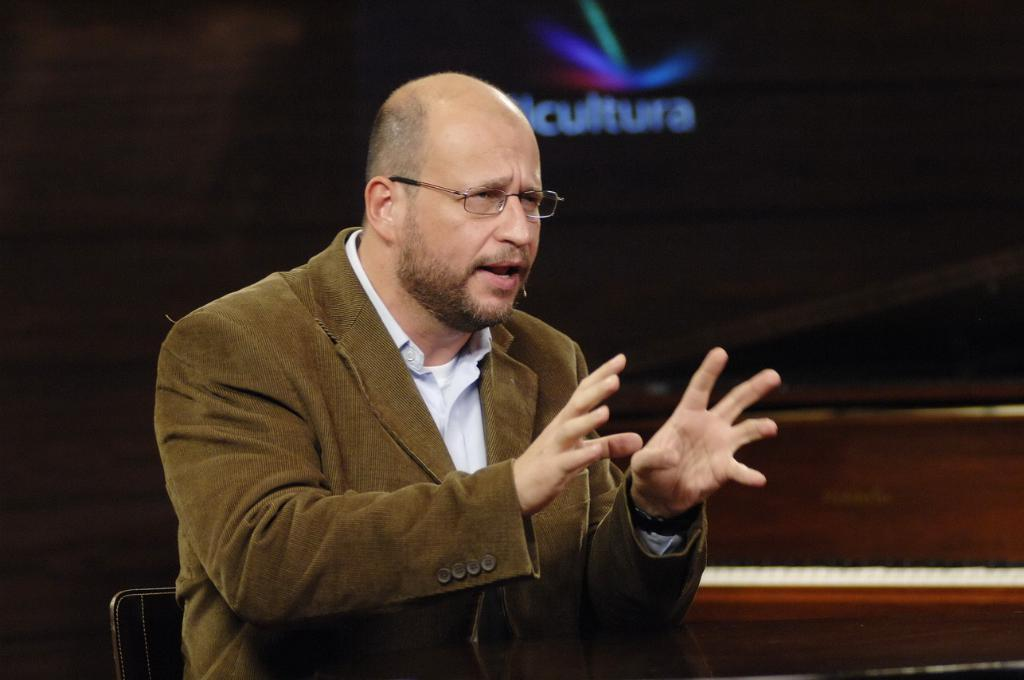What is the man in the image doing? The man is sitting on a chair in the image. What can be observed about the lighting in the image? The background of the image is dark. What else can be seen in the image besides the man sitting on the chair? There are objects visible in the background of the image. What type of poison is the man holding in the image? There is no poison present in the image; the man is simply sitting on a chair. How many jellyfish can be seen swimming in the background of the image? There are no jellyfish present in the image; the background features objects, not marine life. 